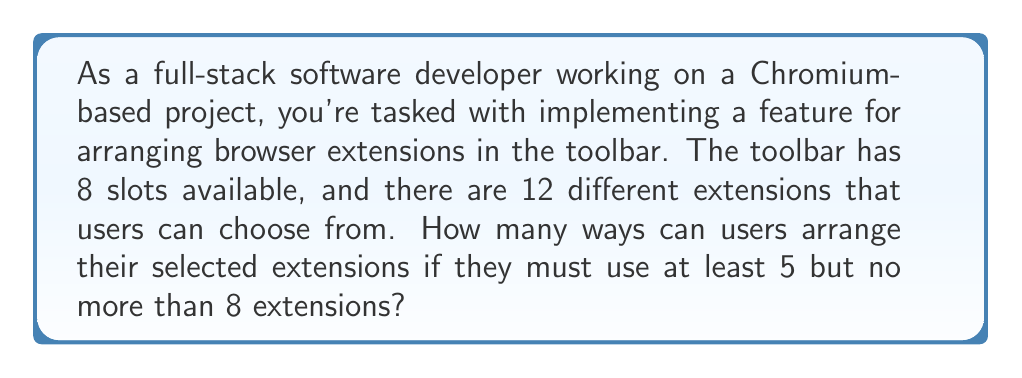Help me with this question. Let's approach this step-by-step:

1) We need to consider arrangements with 5, 6, 7, and 8 extensions.

2) For each case, we need to:
   a) Choose the extensions
   b) Arrange them in the available slots

3) Let's calculate each case:

   For 5 extensions:
   - Choose 5 out of 12: $\binom{12}{5}$
   - Arrange 5 in 8 slots: $P(8,5) = \frac{8!}{(8-5)!} = \frac{8!}{3!}$
   - Total: $\binom{12}{5} \cdot \frac{8!}{3!}$

   For 6 extensions:
   - Choose 6 out of 12: $\binom{12}{6}$
   - Arrange 6 in 8 slots: $P(8,6) = \frac{8!}{(8-6)!} = \frac{8!}{2!}$
   - Total: $\binom{12}{6} \cdot \frac{8!}{2!}$

   For 7 extensions:
   - Choose 7 out of 12: $\binom{12}{7}$
   - Arrange 7 in 8 slots: $P(8,7) = \frac{8!}{(8-7)!} = \frac{8!}{1!}$
   - Total: $\binom{12}{7} \cdot 8!$

   For 8 extensions:
   - Choose 8 out of 12: $\binom{12}{8}$
   - Arrange 8 in 8 slots: $8!$
   - Total: $\binom{12}{8} \cdot 8!$

4) The total number of ways is the sum of all these cases:

   $$\binom{12}{5} \cdot \frac{8!}{3!} + \binom{12}{6} \cdot \frac{8!}{2!} + \binom{12}{7} \cdot 8! + \binom{12}{8} \cdot 8!$$

5) Calculating this:
   $$792 \cdot 6720 + 924 \cdot 20160 + 792 \cdot 40320 + 495 \cdot 40320 = 116,611,200$$

Therefore, there are 116,611,200 ways to arrange the extensions.
Answer: 116,611,200 